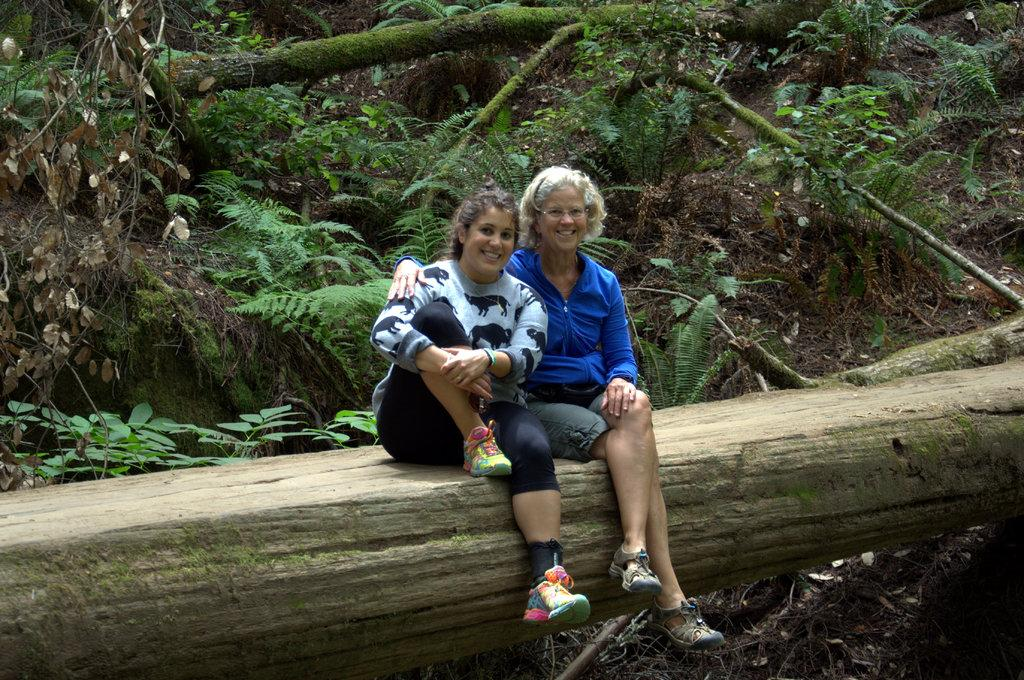How many people are in the image? There are two persons in the image. What are the persons doing in the image? The persons are smiling. Where are the persons sitting in the image? The persons are sitting on a trunk. What can be seen in the background of the image? There are plants in the background of the image. What type of cream can be seen on the land in the image? There is no land or cream present in the image. How many cents are visible on the persons in the image? There are no cents visible on the persons in the image. 